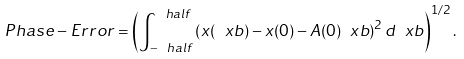<formula> <loc_0><loc_0><loc_500><loc_500>P h a s e - E r r o r = \left ( \int _ { - \ h a l f } ^ { \ h a l f } \left ( x ( \ x b ) - x ( 0 ) - A ( 0 ) \ x b \right ) ^ { 2 } d \ x b \right ) ^ { 1 / 2 } .</formula> 